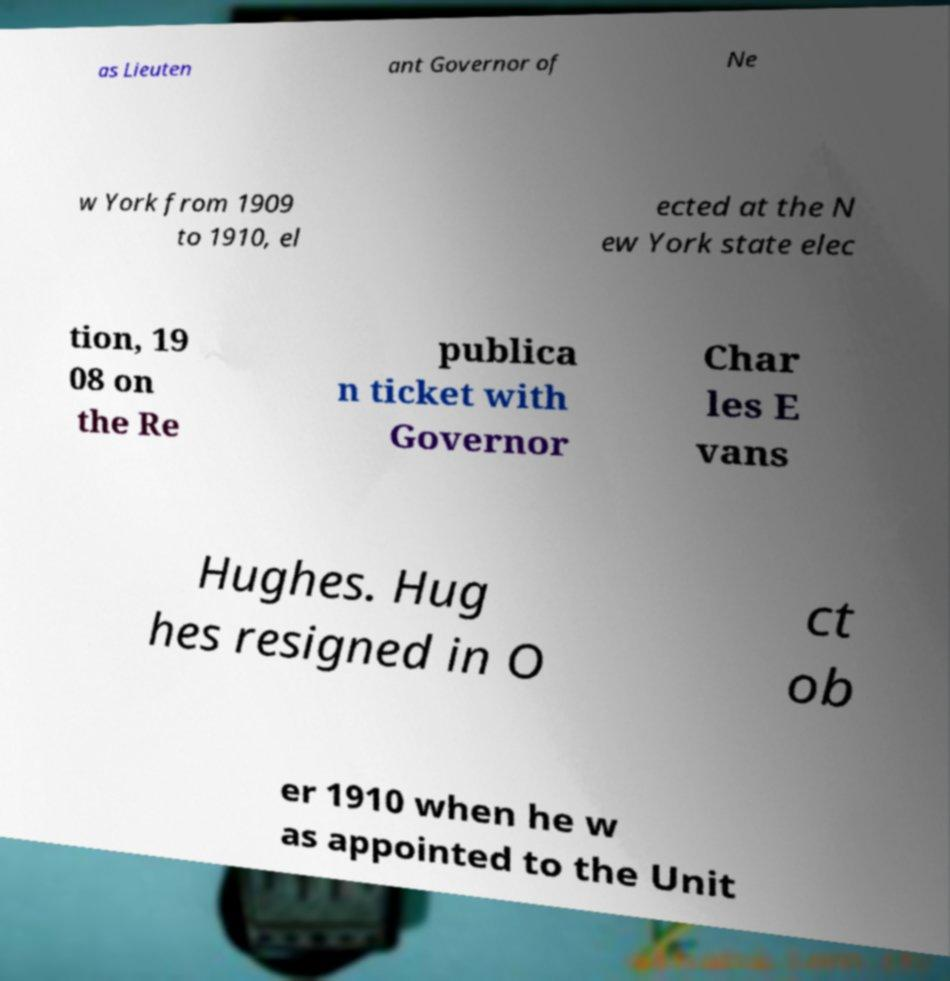For documentation purposes, I need the text within this image transcribed. Could you provide that? as Lieuten ant Governor of Ne w York from 1909 to 1910, el ected at the N ew York state elec tion, 19 08 on the Re publica n ticket with Governor Char les E vans Hughes. Hug hes resigned in O ct ob er 1910 when he w as appointed to the Unit 